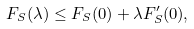<formula> <loc_0><loc_0><loc_500><loc_500>F _ { S } ( \lambda ) \leq F _ { S } ( 0 ) + \lambda F _ { S } ^ { \prime } ( 0 ) ,</formula> 